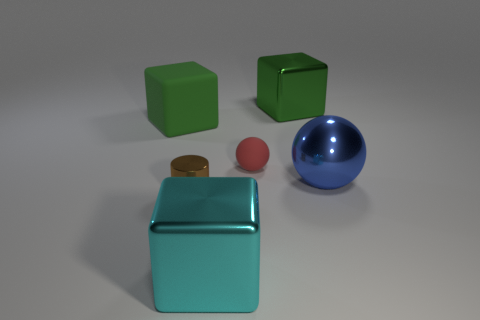Is there anything else that has the same color as the metal ball?
Give a very brief answer. No. The other large shiny object that is the same shape as the green metal thing is what color?
Ensure brevity in your answer.  Cyan. Is the number of small brown metal cylinders behind the green metallic block greater than the number of large cubes?
Ensure brevity in your answer.  No. There is a matte object that is to the right of the small brown cylinder; what color is it?
Your answer should be very brief. Red. Do the cylinder and the cyan object have the same size?
Ensure brevity in your answer.  No. The green rubber cube is what size?
Keep it short and to the point. Large. The metallic thing that is the same color as the large rubber thing is what shape?
Offer a terse response. Cube. Are there more big spheres than yellow matte cylinders?
Provide a short and direct response. Yes. There is a matte object that is on the right side of the block that is to the left of the block that is in front of the green rubber thing; what color is it?
Provide a short and direct response. Red. There is a rubber object on the left side of the small rubber object; is it the same shape as the blue object?
Give a very brief answer. No. 